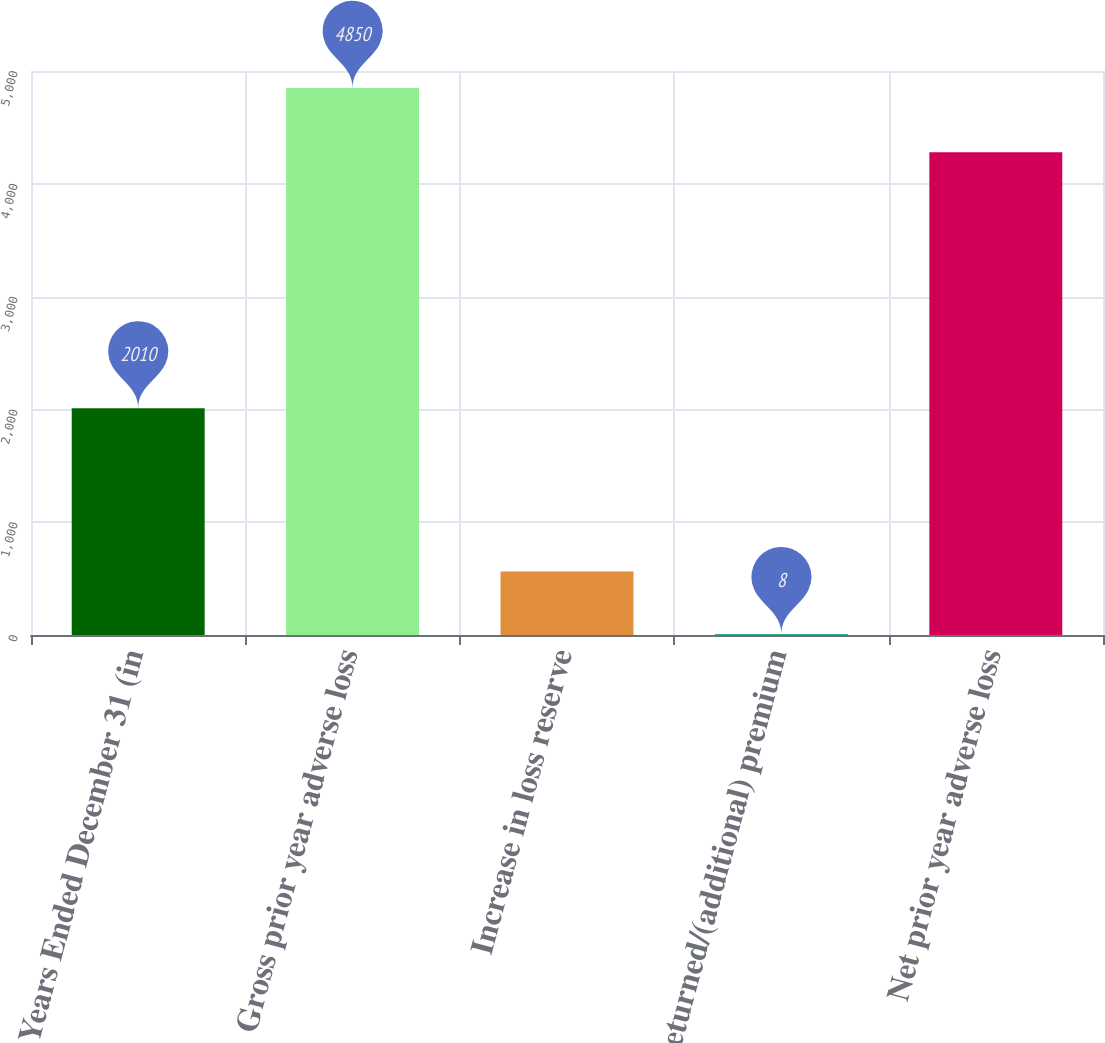<chart> <loc_0><loc_0><loc_500><loc_500><bar_chart><fcel>Years Ended December 31 (in<fcel>Gross prior year adverse loss<fcel>Increase in loss reserve<fcel>Returned/(additional) premium<fcel>Net prior year adverse loss<nl><fcel>2010<fcel>4850<fcel>562<fcel>8<fcel>4280<nl></chart> 